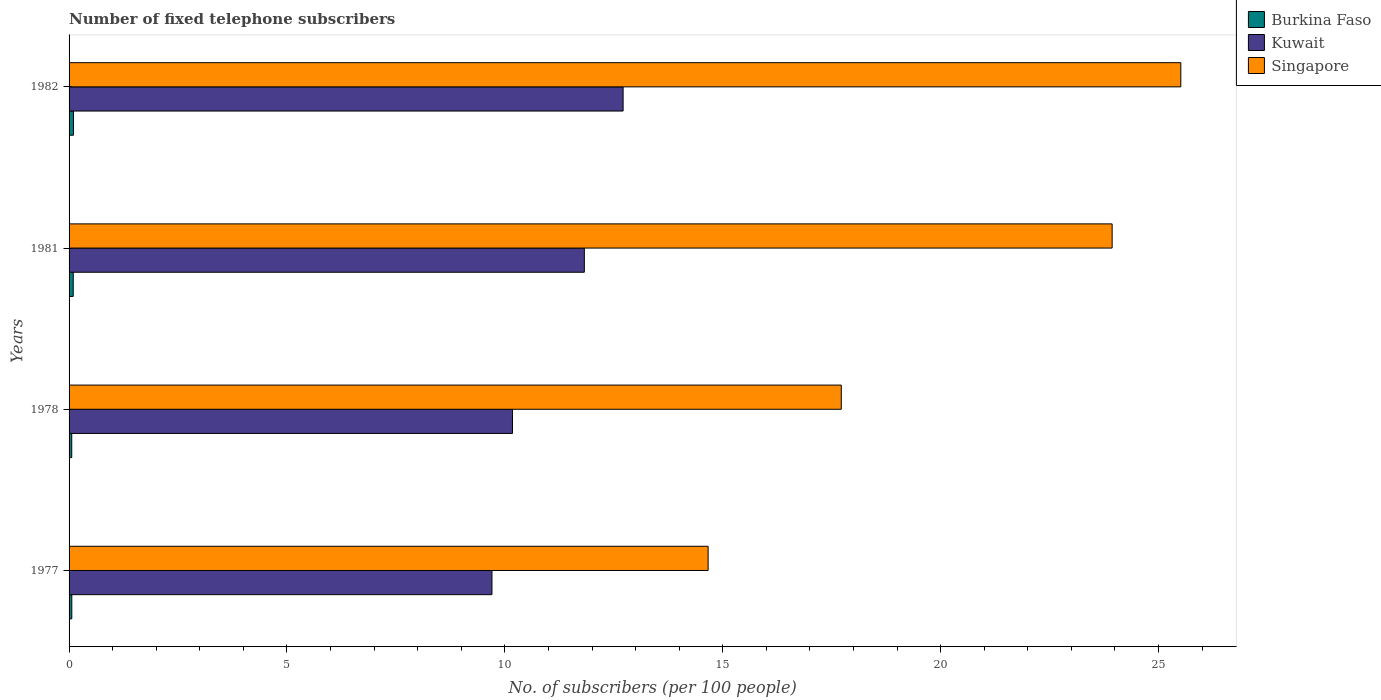How many different coloured bars are there?
Keep it short and to the point. 3. How many bars are there on the 1st tick from the top?
Your answer should be compact. 3. In how many cases, is the number of bars for a given year not equal to the number of legend labels?
Offer a terse response. 0. What is the number of fixed telephone subscribers in Kuwait in 1978?
Offer a terse response. 10.17. Across all years, what is the maximum number of fixed telephone subscribers in Singapore?
Offer a terse response. 25.51. Across all years, what is the minimum number of fixed telephone subscribers in Singapore?
Provide a short and direct response. 14.66. What is the total number of fixed telephone subscribers in Burkina Faso in the graph?
Give a very brief answer. 0.32. What is the difference between the number of fixed telephone subscribers in Burkina Faso in 1978 and that in 1981?
Ensure brevity in your answer.  -0.03. What is the difference between the number of fixed telephone subscribers in Kuwait in 1981 and the number of fixed telephone subscribers in Burkina Faso in 1977?
Keep it short and to the point. 11.76. What is the average number of fixed telephone subscribers in Burkina Faso per year?
Keep it short and to the point. 0.08. In the year 1978, what is the difference between the number of fixed telephone subscribers in Burkina Faso and number of fixed telephone subscribers in Kuwait?
Give a very brief answer. -10.11. What is the ratio of the number of fixed telephone subscribers in Kuwait in 1977 to that in 1978?
Provide a short and direct response. 0.95. Is the number of fixed telephone subscribers in Kuwait in 1977 less than that in 1978?
Keep it short and to the point. Yes. Is the difference between the number of fixed telephone subscribers in Burkina Faso in 1977 and 1982 greater than the difference between the number of fixed telephone subscribers in Kuwait in 1977 and 1982?
Offer a terse response. Yes. What is the difference between the highest and the second highest number of fixed telephone subscribers in Kuwait?
Provide a short and direct response. 0.89. What is the difference between the highest and the lowest number of fixed telephone subscribers in Kuwait?
Offer a very short reply. 3.01. In how many years, is the number of fixed telephone subscribers in Burkina Faso greater than the average number of fixed telephone subscribers in Burkina Faso taken over all years?
Your answer should be compact. 2. Is the sum of the number of fixed telephone subscribers in Burkina Faso in 1978 and 1981 greater than the maximum number of fixed telephone subscribers in Singapore across all years?
Give a very brief answer. No. What does the 3rd bar from the top in 1981 represents?
Provide a succinct answer. Burkina Faso. What does the 3rd bar from the bottom in 1978 represents?
Provide a succinct answer. Singapore. Is it the case that in every year, the sum of the number of fixed telephone subscribers in Kuwait and number of fixed telephone subscribers in Singapore is greater than the number of fixed telephone subscribers in Burkina Faso?
Keep it short and to the point. Yes. How many years are there in the graph?
Your answer should be very brief. 4. Are the values on the major ticks of X-axis written in scientific E-notation?
Give a very brief answer. No. Does the graph contain any zero values?
Offer a terse response. No. How many legend labels are there?
Give a very brief answer. 3. What is the title of the graph?
Your response must be concise. Number of fixed telephone subscribers. What is the label or title of the X-axis?
Provide a succinct answer. No. of subscribers (per 100 people). What is the No. of subscribers (per 100 people) of Burkina Faso in 1977?
Offer a terse response. 0.06. What is the No. of subscribers (per 100 people) in Kuwait in 1977?
Provide a short and direct response. 9.7. What is the No. of subscribers (per 100 people) of Singapore in 1977?
Your response must be concise. 14.66. What is the No. of subscribers (per 100 people) in Burkina Faso in 1978?
Offer a very short reply. 0.06. What is the No. of subscribers (per 100 people) in Kuwait in 1978?
Your answer should be compact. 10.17. What is the No. of subscribers (per 100 people) of Singapore in 1978?
Provide a short and direct response. 17.72. What is the No. of subscribers (per 100 people) of Burkina Faso in 1981?
Offer a very short reply. 0.1. What is the No. of subscribers (per 100 people) of Kuwait in 1981?
Provide a short and direct response. 11.82. What is the No. of subscribers (per 100 people) of Singapore in 1981?
Offer a terse response. 23.94. What is the No. of subscribers (per 100 people) in Burkina Faso in 1982?
Keep it short and to the point. 0.1. What is the No. of subscribers (per 100 people) of Kuwait in 1982?
Your answer should be very brief. 12.71. What is the No. of subscribers (per 100 people) of Singapore in 1982?
Offer a terse response. 25.51. Across all years, what is the maximum No. of subscribers (per 100 people) in Burkina Faso?
Offer a very short reply. 0.1. Across all years, what is the maximum No. of subscribers (per 100 people) of Kuwait?
Provide a succinct answer. 12.71. Across all years, what is the maximum No. of subscribers (per 100 people) in Singapore?
Ensure brevity in your answer.  25.51. Across all years, what is the minimum No. of subscribers (per 100 people) in Burkina Faso?
Give a very brief answer. 0.06. Across all years, what is the minimum No. of subscribers (per 100 people) in Kuwait?
Your response must be concise. 9.7. Across all years, what is the minimum No. of subscribers (per 100 people) in Singapore?
Provide a succinct answer. 14.66. What is the total No. of subscribers (per 100 people) in Burkina Faso in the graph?
Provide a short and direct response. 0.32. What is the total No. of subscribers (per 100 people) in Kuwait in the graph?
Provide a succinct answer. 44.42. What is the total No. of subscribers (per 100 people) of Singapore in the graph?
Provide a short and direct response. 81.83. What is the difference between the No. of subscribers (per 100 people) in Burkina Faso in 1977 and that in 1978?
Give a very brief answer. 0. What is the difference between the No. of subscribers (per 100 people) in Kuwait in 1977 and that in 1978?
Make the answer very short. -0.47. What is the difference between the No. of subscribers (per 100 people) of Singapore in 1977 and that in 1978?
Ensure brevity in your answer.  -3.06. What is the difference between the No. of subscribers (per 100 people) in Burkina Faso in 1977 and that in 1981?
Provide a short and direct response. -0.03. What is the difference between the No. of subscribers (per 100 people) of Kuwait in 1977 and that in 1981?
Ensure brevity in your answer.  -2.12. What is the difference between the No. of subscribers (per 100 people) in Singapore in 1977 and that in 1981?
Provide a short and direct response. -9.27. What is the difference between the No. of subscribers (per 100 people) of Burkina Faso in 1977 and that in 1982?
Provide a short and direct response. -0.04. What is the difference between the No. of subscribers (per 100 people) in Kuwait in 1977 and that in 1982?
Provide a short and direct response. -3.01. What is the difference between the No. of subscribers (per 100 people) in Singapore in 1977 and that in 1982?
Offer a very short reply. -10.85. What is the difference between the No. of subscribers (per 100 people) in Burkina Faso in 1978 and that in 1981?
Provide a short and direct response. -0.03. What is the difference between the No. of subscribers (per 100 people) of Kuwait in 1978 and that in 1981?
Ensure brevity in your answer.  -1.65. What is the difference between the No. of subscribers (per 100 people) of Singapore in 1978 and that in 1981?
Make the answer very short. -6.22. What is the difference between the No. of subscribers (per 100 people) of Burkina Faso in 1978 and that in 1982?
Your response must be concise. -0.04. What is the difference between the No. of subscribers (per 100 people) of Kuwait in 1978 and that in 1982?
Make the answer very short. -2.54. What is the difference between the No. of subscribers (per 100 people) in Singapore in 1978 and that in 1982?
Keep it short and to the point. -7.79. What is the difference between the No. of subscribers (per 100 people) in Burkina Faso in 1981 and that in 1982?
Your response must be concise. -0. What is the difference between the No. of subscribers (per 100 people) in Kuwait in 1981 and that in 1982?
Give a very brief answer. -0.89. What is the difference between the No. of subscribers (per 100 people) in Singapore in 1981 and that in 1982?
Your answer should be very brief. -1.58. What is the difference between the No. of subscribers (per 100 people) of Burkina Faso in 1977 and the No. of subscribers (per 100 people) of Kuwait in 1978?
Provide a succinct answer. -10.11. What is the difference between the No. of subscribers (per 100 people) of Burkina Faso in 1977 and the No. of subscribers (per 100 people) of Singapore in 1978?
Your answer should be compact. -17.66. What is the difference between the No. of subscribers (per 100 people) of Kuwait in 1977 and the No. of subscribers (per 100 people) of Singapore in 1978?
Make the answer very short. -8.02. What is the difference between the No. of subscribers (per 100 people) in Burkina Faso in 1977 and the No. of subscribers (per 100 people) in Kuwait in 1981?
Your response must be concise. -11.76. What is the difference between the No. of subscribers (per 100 people) in Burkina Faso in 1977 and the No. of subscribers (per 100 people) in Singapore in 1981?
Make the answer very short. -23.87. What is the difference between the No. of subscribers (per 100 people) of Kuwait in 1977 and the No. of subscribers (per 100 people) of Singapore in 1981?
Make the answer very short. -14.23. What is the difference between the No. of subscribers (per 100 people) of Burkina Faso in 1977 and the No. of subscribers (per 100 people) of Kuwait in 1982?
Offer a very short reply. -12.65. What is the difference between the No. of subscribers (per 100 people) in Burkina Faso in 1977 and the No. of subscribers (per 100 people) in Singapore in 1982?
Ensure brevity in your answer.  -25.45. What is the difference between the No. of subscribers (per 100 people) of Kuwait in 1977 and the No. of subscribers (per 100 people) of Singapore in 1982?
Your answer should be compact. -15.81. What is the difference between the No. of subscribers (per 100 people) of Burkina Faso in 1978 and the No. of subscribers (per 100 people) of Kuwait in 1981?
Provide a short and direct response. -11.76. What is the difference between the No. of subscribers (per 100 people) of Burkina Faso in 1978 and the No. of subscribers (per 100 people) of Singapore in 1981?
Provide a short and direct response. -23.87. What is the difference between the No. of subscribers (per 100 people) of Kuwait in 1978 and the No. of subscribers (per 100 people) of Singapore in 1981?
Offer a very short reply. -13.76. What is the difference between the No. of subscribers (per 100 people) in Burkina Faso in 1978 and the No. of subscribers (per 100 people) in Kuwait in 1982?
Your answer should be very brief. -12.65. What is the difference between the No. of subscribers (per 100 people) in Burkina Faso in 1978 and the No. of subscribers (per 100 people) in Singapore in 1982?
Keep it short and to the point. -25.45. What is the difference between the No. of subscribers (per 100 people) in Kuwait in 1978 and the No. of subscribers (per 100 people) in Singapore in 1982?
Provide a succinct answer. -15.34. What is the difference between the No. of subscribers (per 100 people) of Burkina Faso in 1981 and the No. of subscribers (per 100 people) of Kuwait in 1982?
Your answer should be compact. -12.62. What is the difference between the No. of subscribers (per 100 people) of Burkina Faso in 1981 and the No. of subscribers (per 100 people) of Singapore in 1982?
Keep it short and to the point. -25.42. What is the difference between the No. of subscribers (per 100 people) in Kuwait in 1981 and the No. of subscribers (per 100 people) in Singapore in 1982?
Provide a short and direct response. -13.69. What is the average No. of subscribers (per 100 people) of Burkina Faso per year?
Offer a terse response. 0.08. What is the average No. of subscribers (per 100 people) of Kuwait per year?
Your response must be concise. 11.1. What is the average No. of subscribers (per 100 people) of Singapore per year?
Make the answer very short. 20.46. In the year 1977, what is the difference between the No. of subscribers (per 100 people) of Burkina Faso and No. of subscribers (per 100 people) of Kuwait?
Keep it short and to the point. -9.64. In the year 1977, what is the difference between the No. of subscribers (per 100 people) of Burkina Faso and No. of subscribers (per 100 people) of Singapore?
Offer a terse response. -14.6. In the year 1977, what is the difference between the No. of subscribers (per 100 people) of Kuwait and No. of subscribers (per 100 people) of Singapore?
Give a very brief answer. -4.96. In the year 1978, what is the difference between the No. of subscribers (per 100 people) in Burkina Faso and No. of subscribers (per 100 people) in Kuwait?
Your answer should be very brief. -10.11. In the year 1978, what is the difference between the No. of subscribers (per 100 people) of Burkina Faso and No. of subscribers (per 100 people) of Singapore?
Provide a short and direct response. -17.66. In the year 1978, what is the difference between the No. of subscribers (per 100 people) of Kuwait and No. of subscribers (per 100 people) of Singapore?
Your answer should be compact. -7.55. In the year 1981, what is the difference between the No. of subscribers (per 100 people) of Burkina Faso and No. of subscribers (per 100 people) of Kuwait?
Your answer should be compact. -11.73. In the year 1981, what is the difference between the No. of subscribers (per 100 people) in Burkina Faso and No. of subscribers (per 100 people) in Singapore?
Ensure brevity in your answer.  -23.84. In the year 1981, what is the difference between the No. of subscribers (per 100 people) in Kuwait and No. of subscribers (per 100 people) in Singapore?
Your answer should be very brief. -12.11. In the year 1982, what is the difference between the No. of subscribers (per 100 people) in Burkina Faso and No. of subscribers (per 100 people) in Kuwait?
Give a very brief answer. -12.61. In the year 1982, what is the difference between the No. of subscribers (per 100 people) of Burkina Faso and No. of subscribers (per 100 people) of Singapore?
Provide a short and direct response. -25.41. In the year 1982, what is the difference between the No. of subscribers (per 100 people) of Kuwait and No. of subscribers (per 100 people) of Singapore?
Provide a succinct answer. -12.8. What is the ratio of the No. of subscribers (per 100 people) in Burkina Faso in 1977 to that in 1978?
Give a very brief answer. 1.02. What is the ratio of the No. of subscribers (per 100 people) in Kuwait in 1977 to that in 1978?
Your answer should be very brief. 0.95. What is the ratio of the No. of subscribers (per 100 people) of Singapore in 1977 to that in 1978?
Ensure brevity in your answer.  0.83. What is the ratio of the No. of subscribers (per 100 people) of Burkina Faso in 1977 to that in 1981?
Give a very brief answer. 0.65. What is the ratio of the No. of subscribers (per 100 people) in Kuwait in 1977 to that in 1981?
Give a very brief answer. 0.82. What is the ratio of the No. of subscribers (per 100 people) in Singapore in 1977 to that in 1981?
Provide a succinct answer. 0.61. What is the ratio of the No. of subscribers (per 100 people) of Burkina Faso in 1977 to that in 1982?
Offer a terse response. 0.62. What is the ratio of the No. of subscribers (per 100 people) in Kuwait in 1977 to that in 1982?
Your answer should be very brief. 0.76. What is the ratio of the No. of subscribers (per 100 people) of Singapore in 1977 to that in 1982?
Your answer should be very brief. 0.57. What is the ratio of the No. of subscribers (per 100 people) in Burkina Faso in 1978 to that in 1981?
Make the answer very short. 0.64. What is the ratio of the No. of subscribers (per 100 people) of Kuwait in 1978 to that in 1981?
Your answer should be very brief. 0.86. What is the ratio of the No. of subscribers (per 100 people) in Singapore in 1978 to that in 1981?
Offer a very short reply. 0.74. What is the ratio of the No. of subscribers (per 100 people) of Burkina Faso in 1978 to that in 1982?
Your answer should be compact. 0.61. What is the ratio of the No. of subscribers (per 100 people) of Kuwait in 1978 to that in 1982?
Provide a succinct answer. 0.8. What is the ratio of the No. of subscribers (per 100 people) of Singapore in 1978 to that in 1982?
Your response must be concise. 0.69. What is the ratio of the No. of subscribers (per 100 people) in Burkina Faso in 1981 to that in 1982?
Keep it short and to the point. 0.95. What is the ratio of the No. of subscribers (per 100 people) of Singapore in 1981 to that in 1982?
Your response must be concise. 0.94. What is the difference between the highest and the second highest No. of subscribers (per 100 people) of Burkina Faso?
Ensure brevity in your answer.  0. What is the difference between the highest and the second highest No. of subscribers (per 100 people) of Kuwait?
Provide a succinct answer. 0.89. What is the difference between the highest and the second highest No. of subscribers (per 100 people) of Singapore?
Give a very brief answer. 1.58. What is the difference between the highest and the lowest No. of subscribers (per 100 people) in Burkina Faso?
Your answer should be very brief. 0.04. What is the difference between the highest and the lowest No. of subscribers (per 100 people) of Kuwait?
Provide a short and direct response. 3.01. What is the difference between the highest and the lowest No. of subscribers (per 100 people) of Singapore?
Offer a terse response. 10.85. 